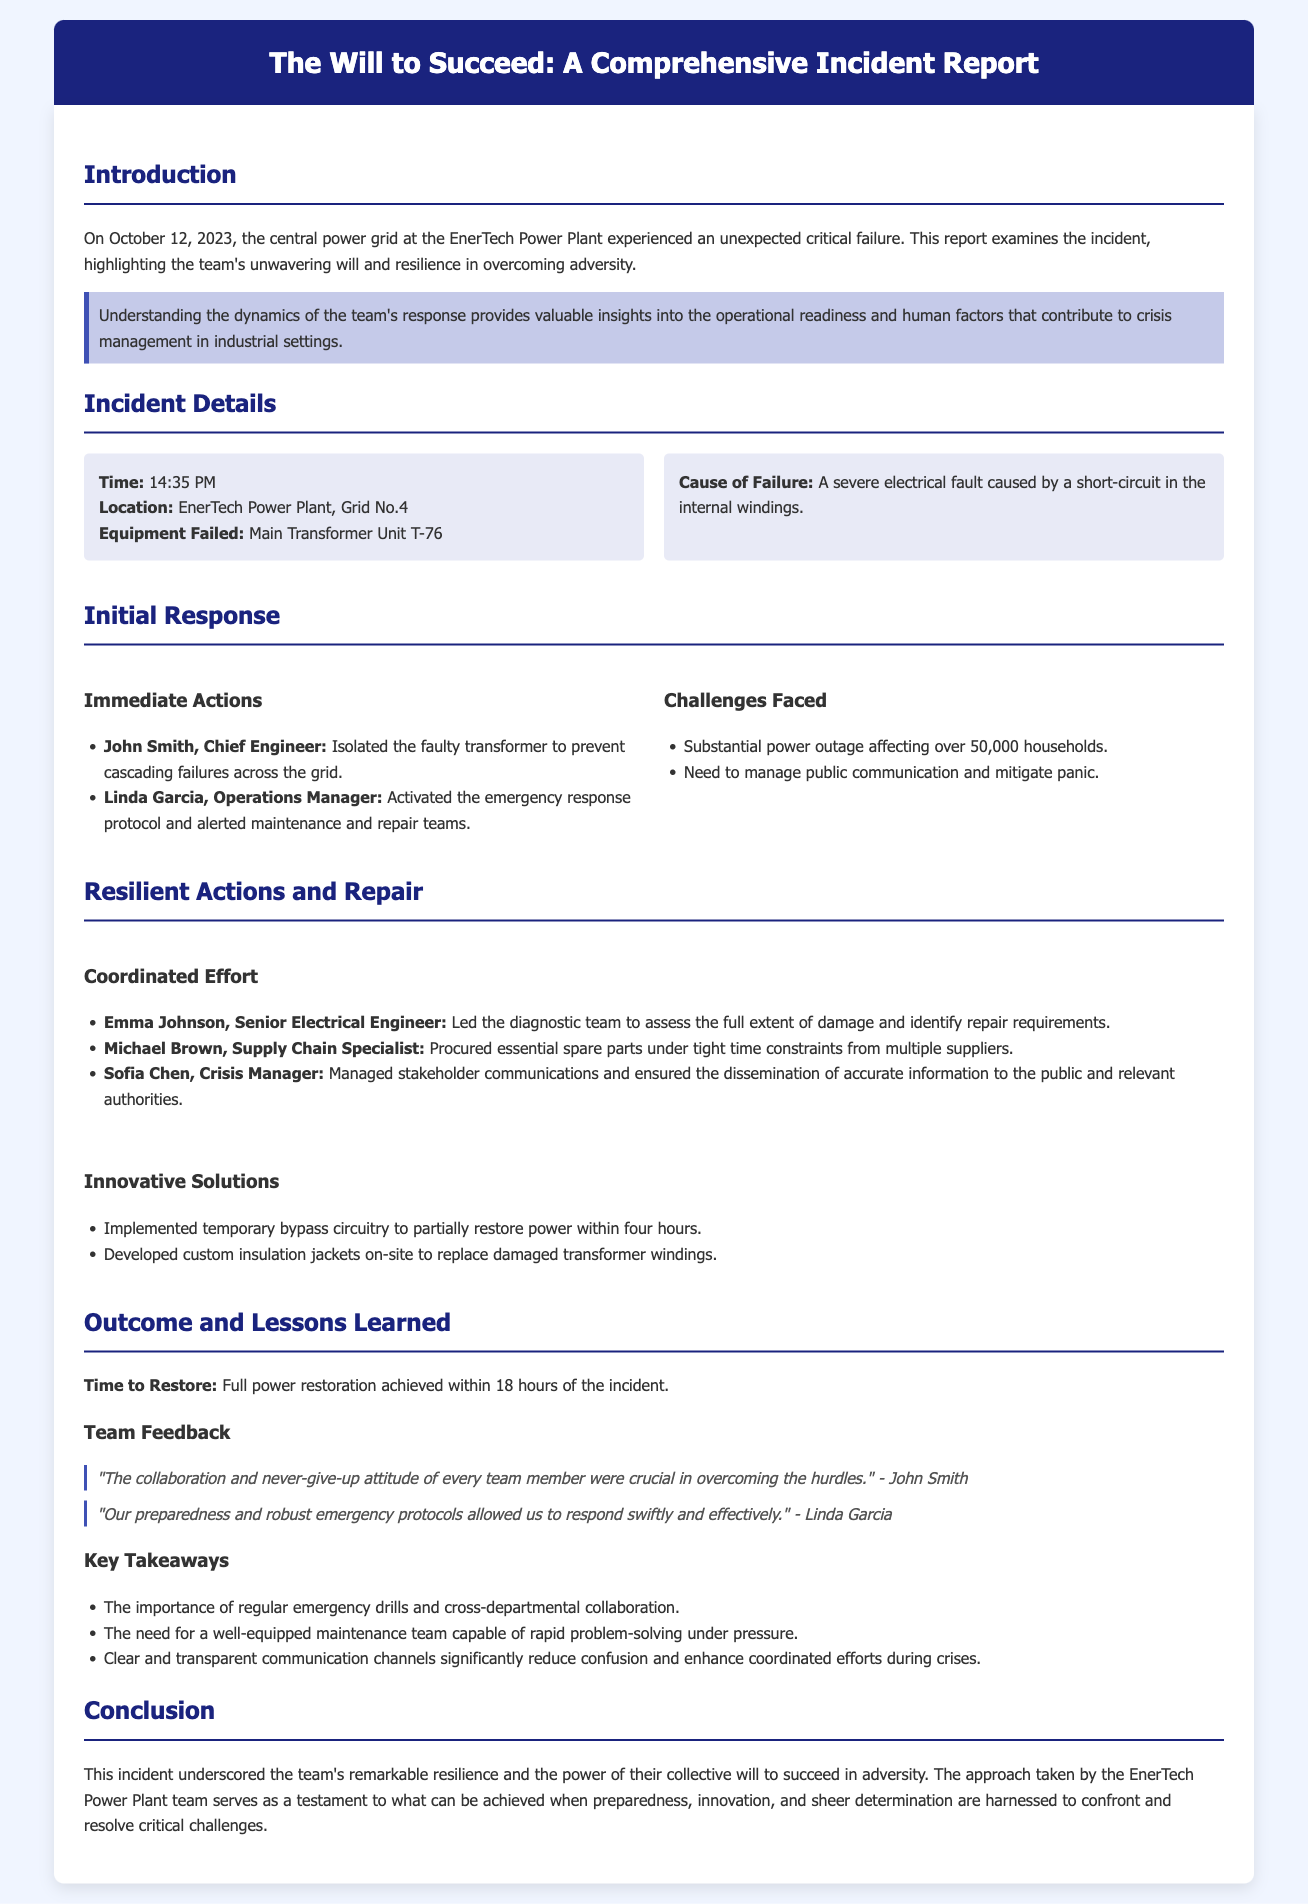What was the date of the incident? The date of the incident is specified in the introduction section of the document.
Answer: October 12, 2023 What equipment failed during the incident? The equipment that failed is mentioned in the incident details section.
Answer: Main Transformer Unit T-76 Who activated the emergency response protocol? The person who activated this protocol is listed under immediate actions in the initial response section.
Answer: Linda Garcia How many households were affected by the power outage? The number of affected households is mentioned in the challenges faced subsection.
Answer: 50,000 What innovative solution was implemented to restore power? The document lists a specific innovative solution in the resilient actions and repair section.
Answer: Temporary bypass circuitry What was the total time to restore full power? The time to restore power is stated in the outcome section.
Answer: 18 hours What did John Smith say about the team's collaboration? The feedback from John Smith is quoted in the team feedback section.
Answer: "The collaboration and never-give-up attitude of every team member were crucial in overcoming the hurdles." What lesson emphasizes the need for regular emergency drills? This lesson is highlighted in the key takeaways section of the report.
Answer: The importance of regular emergency drills and cross-departmental collaboration What does the conclusion highlight about the team's response? The conclusion summarizes the overall message regarding the team's efforts during the incident.
Answer: The team's remarkable resilience and the power of their collective will to succeed in adversity 